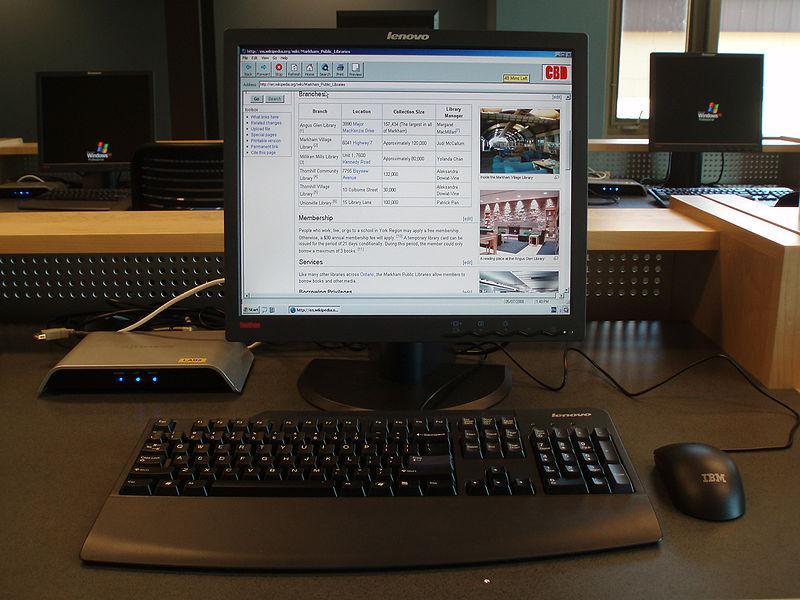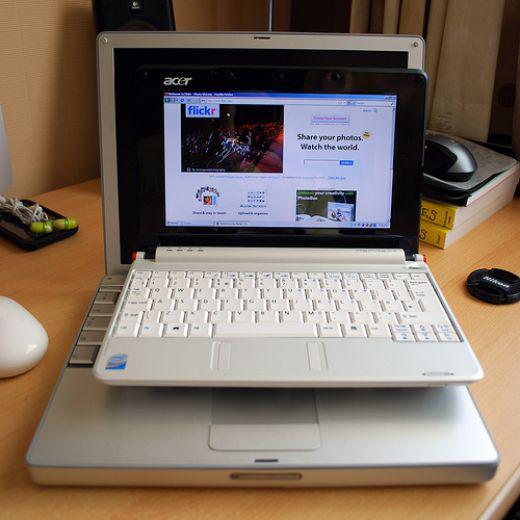The first image is the image on the left, the second image is the image on the right. For the images displayed, is the sentence "One image shows a suite of devices on a plain background." factually correct? Answer yes or no. No. 